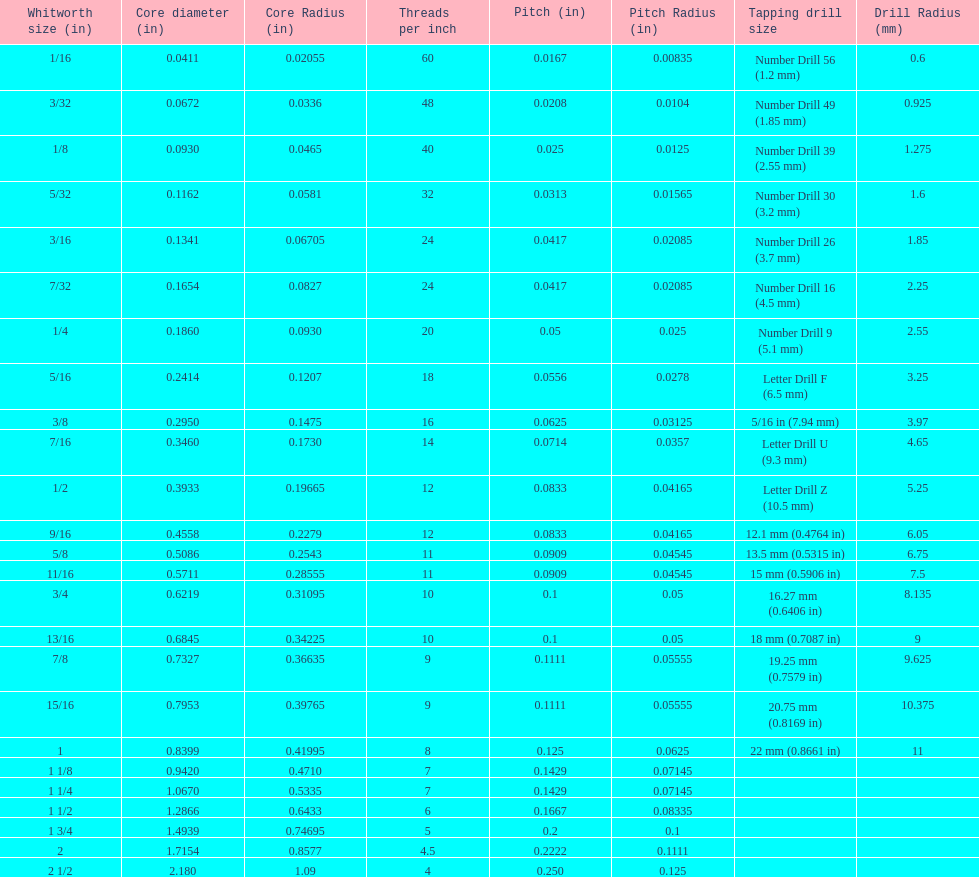What is the least core diameter (in)? 0.0411. 